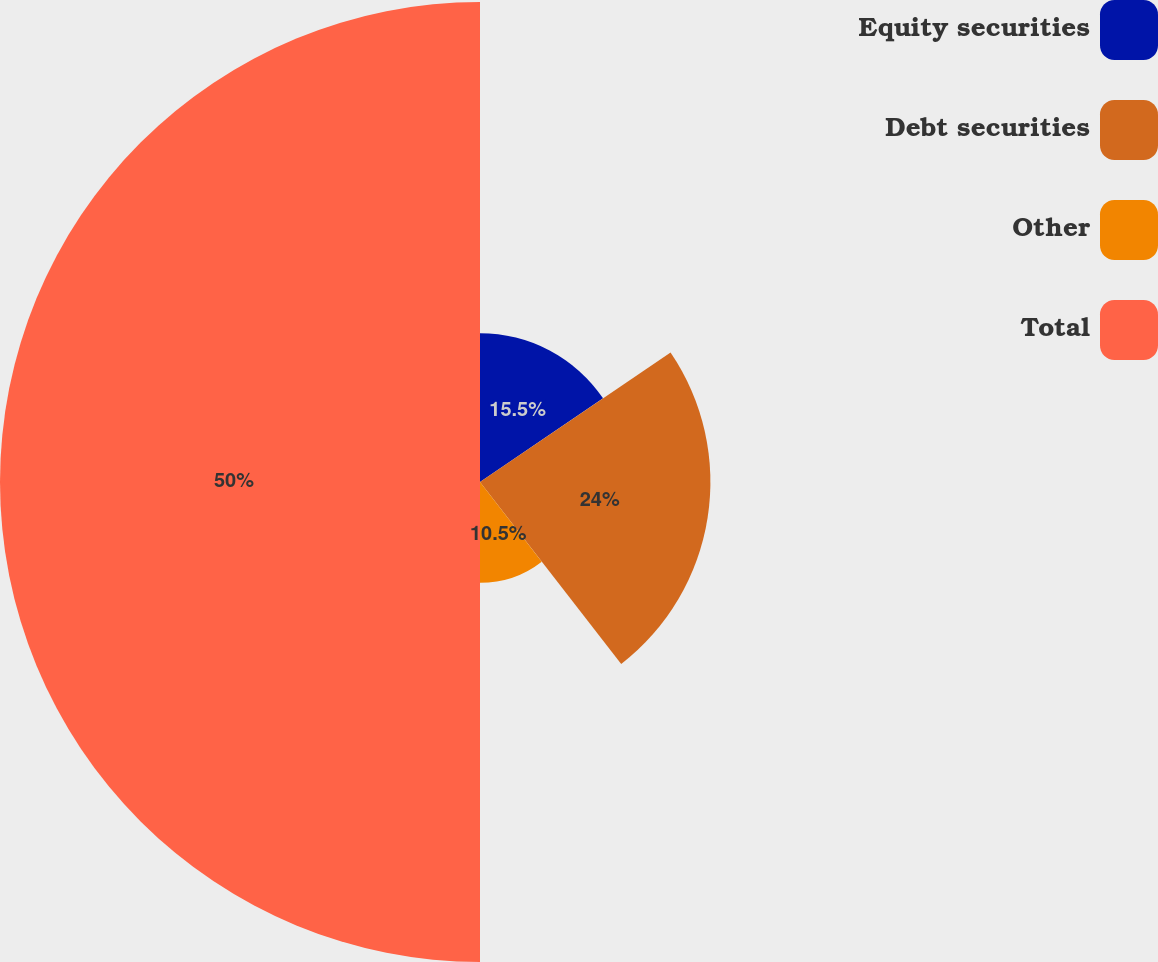<chart> <loc_0><loc_0><loc_500><loc_500><pie_chart><fcel>Equity securities<fcel>Debt securities<fcel>Other<fcel>Total<nl><fcel>15.5%<fcel>24.0%<fcel>10.5%<fcel>50.0%<nl></chart> 